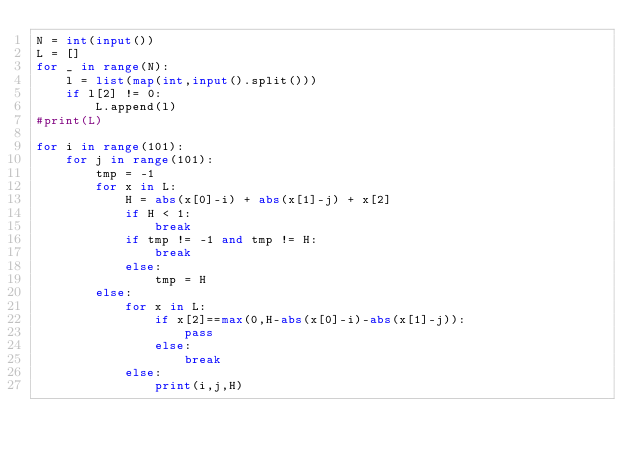Convert code to text. <code><loc_0><loc_0><loc_500><loc_500><_Python_>N = int(input())
L = []
for _ in range(N):
    l = list(map(int,input().split()))
    if l[2] != 0:
        L.append(l)
#print(L)

for i in range(101):
    for j in range(101):
        tmp = -1
        for x in L:
            H = abs(x[0]-i) + abs(x[1]-j) + x[2]
            if H < 1:
                break
            if tmp != -1 and tmp != H:
                break
            else:
                tmp = H
        else:
            for x in L:
                if x[2]==max(0,H-abs(x[0]-i)-abs(x[1]-j)):
                    pass
                else:
                    break
            else:
                print(i,j,H)</code> 